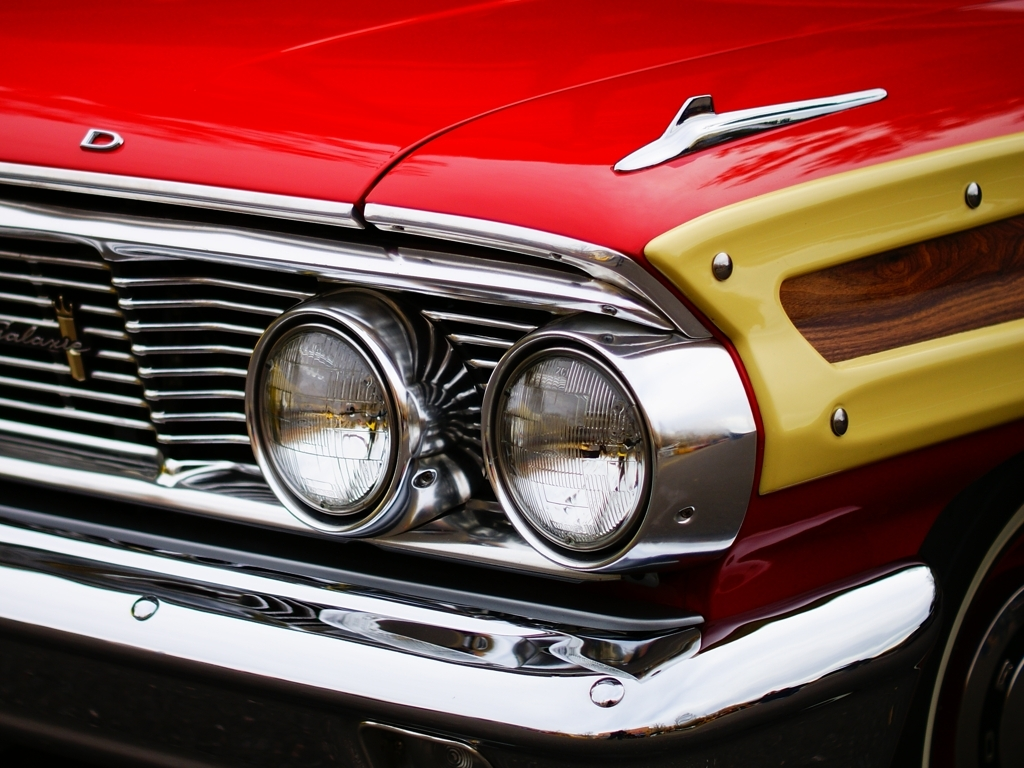Could you comment on the condition of this car? From what is visible in this image, the car appears to be in exceptional condition, with its glossy paint, unblemished chrome accents, and what seems like a well-maintained wooden panel insert. The reflection on the paint and chrome implies a recent restoration or meticulous upkeep. 